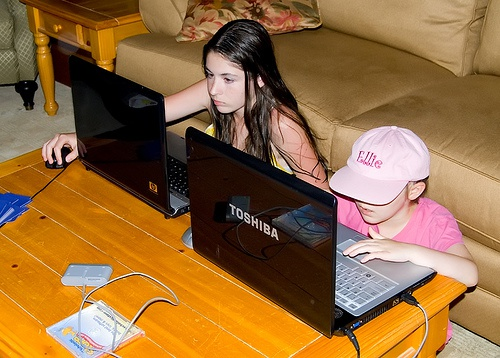Describe the objects in this image and their specific colors. I can see couch in darkgreen, olive, and tan tones, laptop in darkgreen, black, darkgray, maroon, and lightgray tones, people in darkgreen, black, lightpink, and gray tones, people in darkgreen, lavender, lightpink, and tan tones, and laptop in darkgreen, black, maroon, and gray tones in this image. 